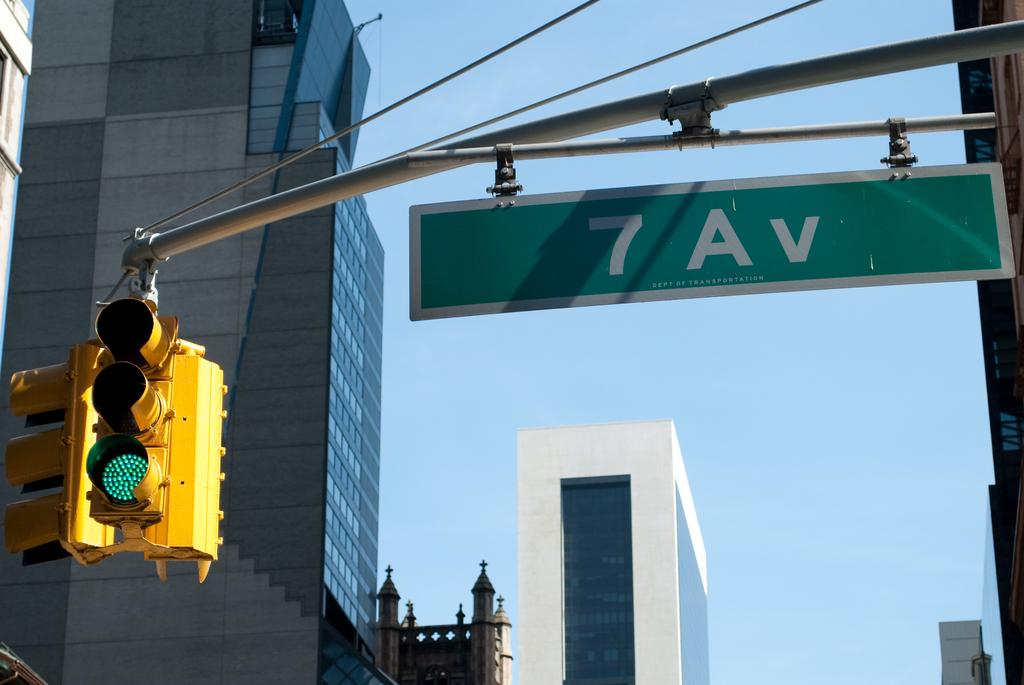<image>
Render a clear and concise summary of the photo. A sign that has 7 Av on it in green 